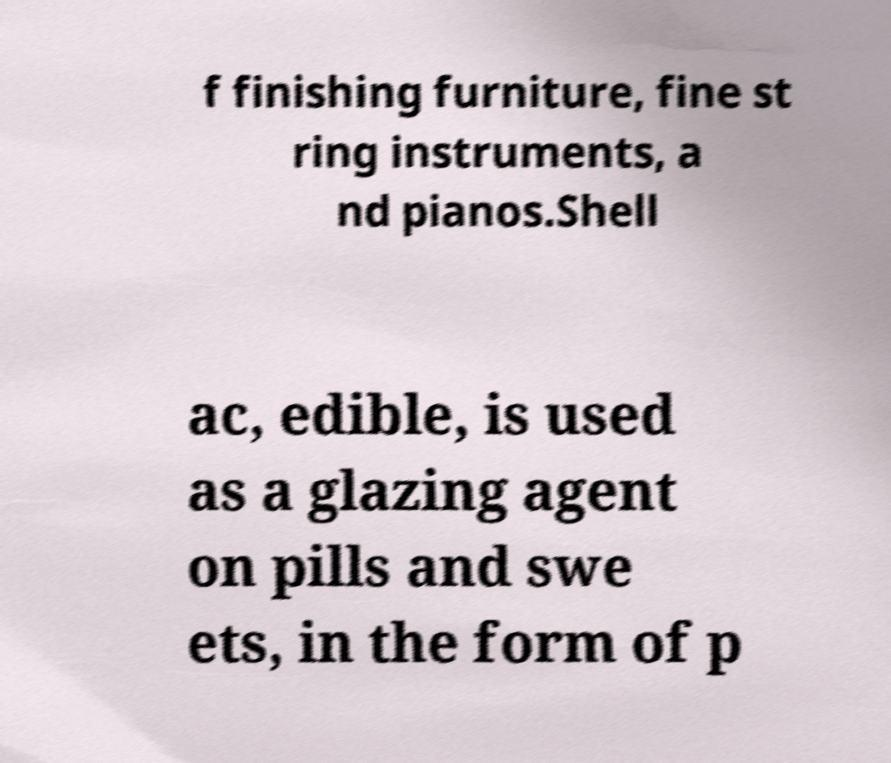Please read and relay the text visible in this image. What does it say? f finishing furniture, fine st ring instruments, a nd pianos.Shell ac, edible, is used as a glazing agent on pills and swe ets, in the form of p 